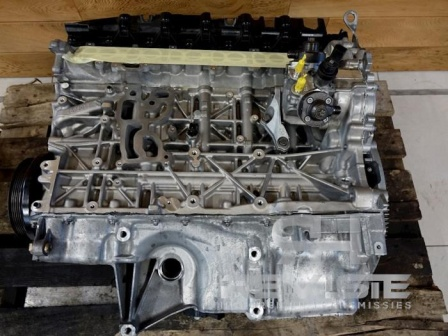Imagine this engine block could talk. What story might it tell about its history and future? If this engine block could talk, it might share tales of countless kilometers traveled, the roaring of its cylinders as it powered a vehicle through every terrain, and the meticulous care it received from devoted mechanics. It might reminisce about the smooth highways and bumpy off-road adventures it endured. The engine block could express hope for a new life, perhaps being restored to power another vehicle or even being used in a unique project like a custom-built car or a display piece in an auto show. 